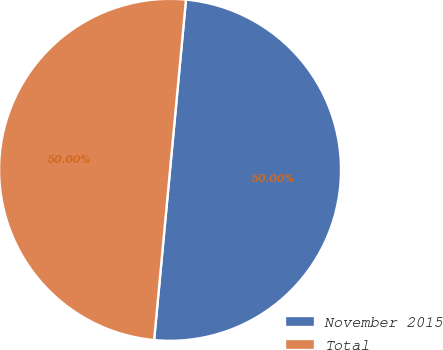<chart> <loc_0><loc_0><loc_500><loc_500><pie_chart><fcel>November 2015<fcel>Total<nl><fcel>50.0%<fcel>50.0%<nl></chart> 